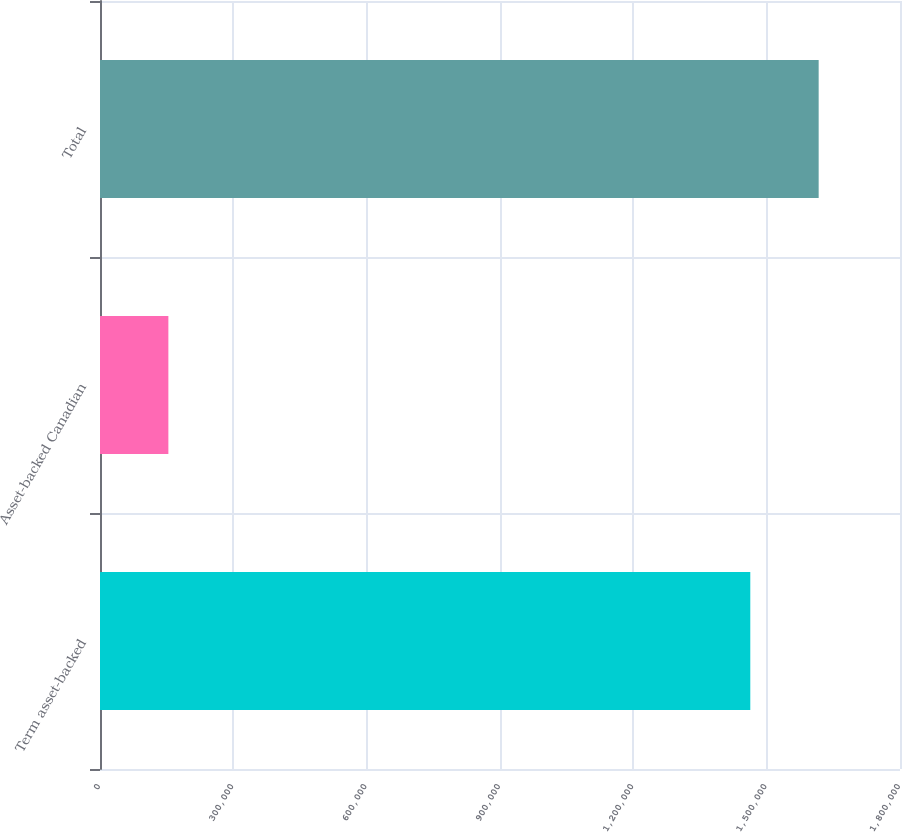Convert chart to OTSL. <chart><loc_0><loc_0><loc_500><loc_500><bar_chart><fcel>Term asset-backed<fcel>Asset-backed Canadian<fcel>Total<nl><fcel>1.46315e+06<fcel>153839<fcel>1.61699e+06<nl></chart> 